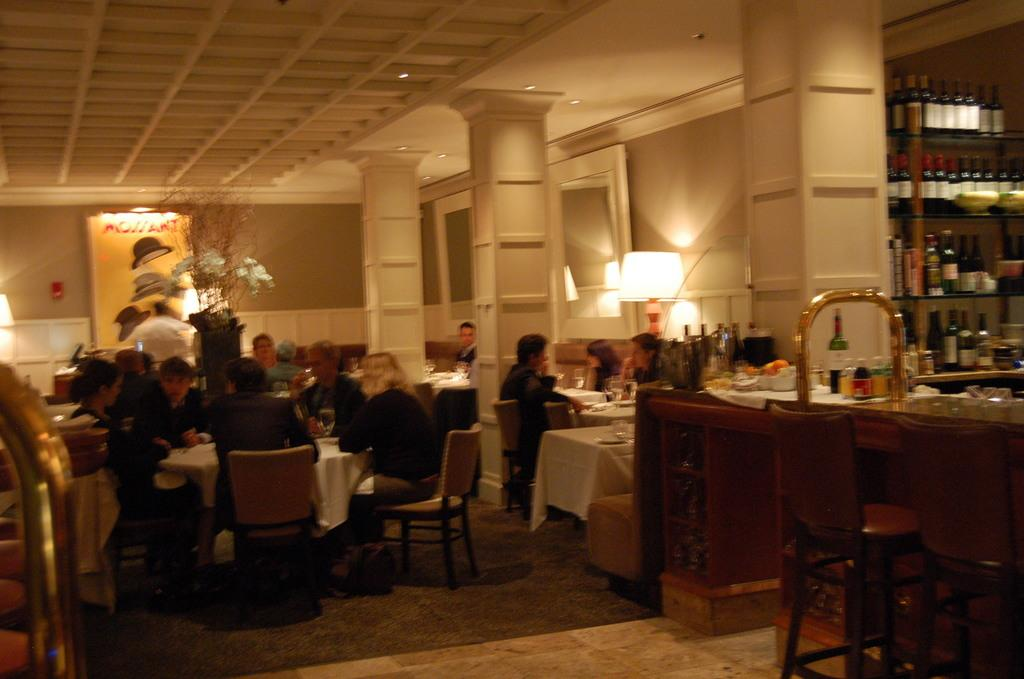What are the people in the image doing? The people in the image are sitting together around a table. Can you describe the lighting in the image? There is a light on the right side of the image. What else can be seen on the right side of the image? There are wine bottles in a rack on the right side of the image. What type of card game are the people playing in the image? There is no card game visible in the image; the people are simply sitting together around a table. What kind of rice is being served with the wine in the image? There is no rice present in the image; only wine bottles in a rack are visible. 